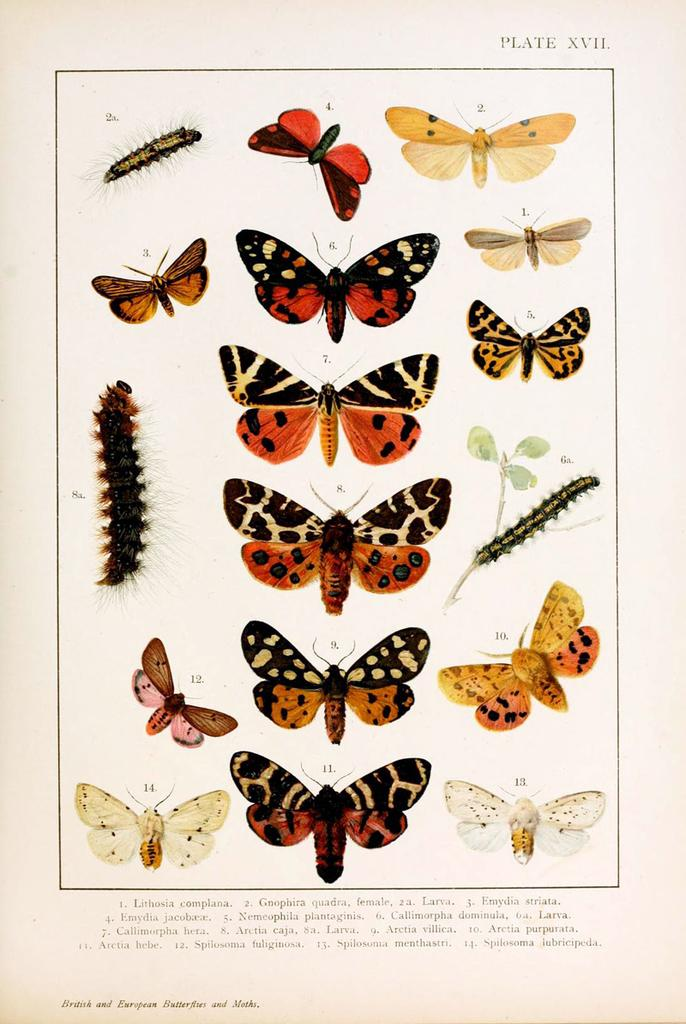What is the main subject of the paper in the image? The paper contains images of insects and butterflies. What types of insects are depicted on the paper? The paper contains images of butterflies. Are the insects and butterflies depicted in a single color or multiple colors? The insects and butterflies are depicted in multiple colors. What month is depicted on the paper? There is no month depicted on the paper; it contains images of insects and butterflies. Can you tell me how many ears are visible on the paper? There are no ears depicted on the paper; it contains images of insects and butterflies. 